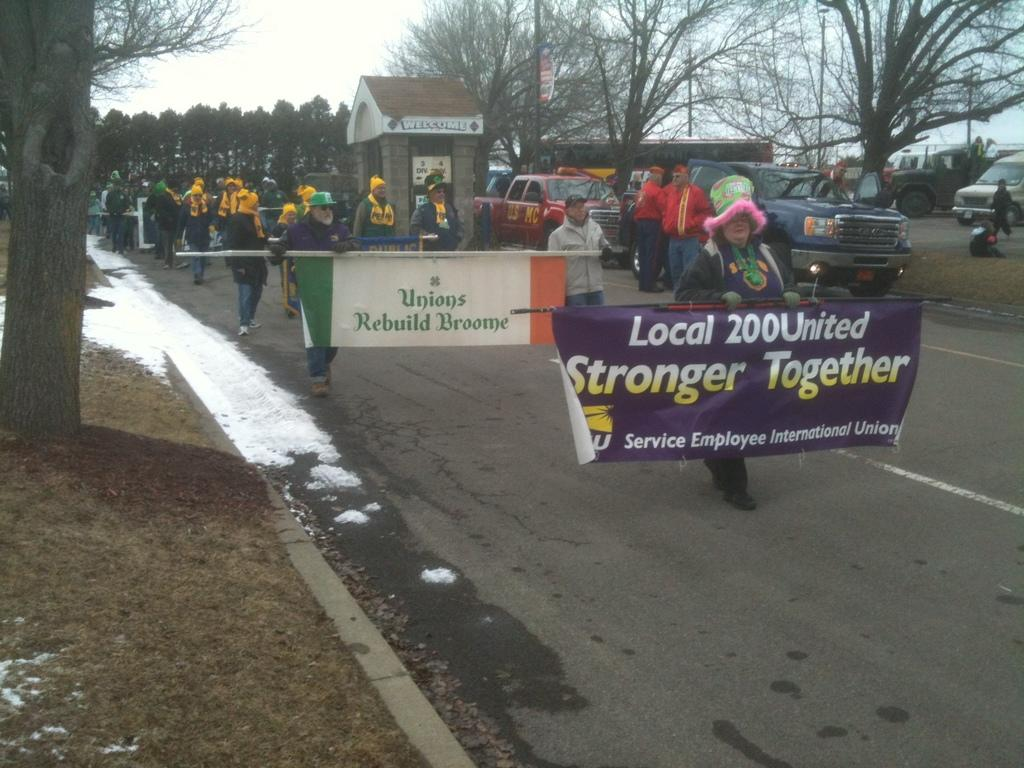Provide a one-sentence caption for the provided image. People holding a purple sign which says "Stronger Together". 